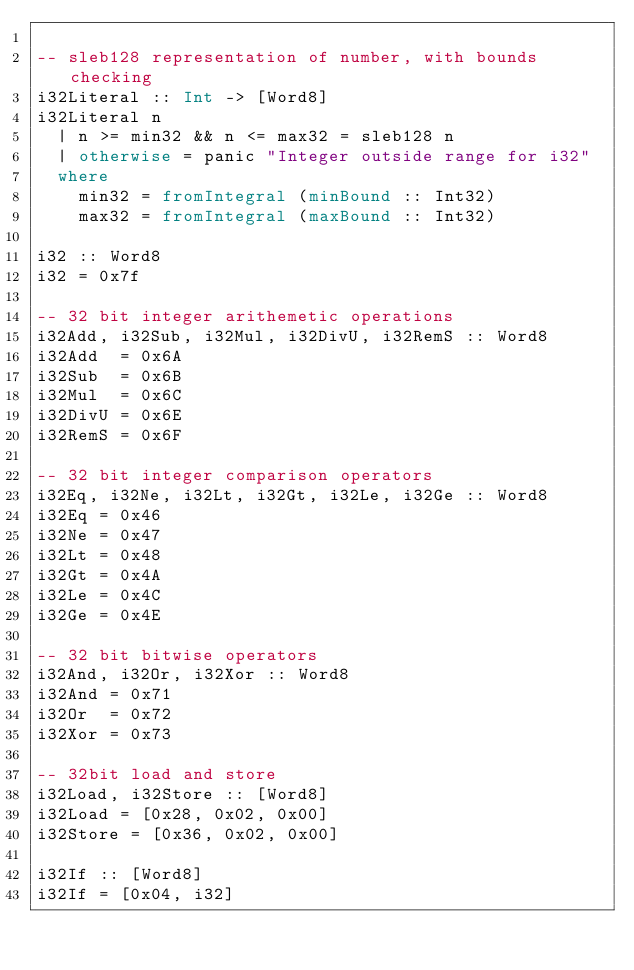Convert code to text. <code><loc_0><loc_0><loc_500><loc_500><_Haskell_>
-- sleb128 representation of number, with bounds checking
i32Literal :: Int -> [Word8]
i32Literal n
  | n >= min32 && n <= max32 = sleb128 n
  | otherwise = panic "Integer outside range for i32"
  where
    min32 = fromIntegral (minBound :: Int32)
    max32 = fromIntegral (maxBound :: Int32)

i32 :: Word8
i32 = 0x7f

-- 32 bit integer arithemetic operations
i32Add, i32Sub, i32Mul, i32DivU, i32RemS :: Word8
i32Add  = 0x6A
i32Sub  = 0x6B
i32Mul  = 0x6C
i32DivU = 0x6E
i32RemS = 0x6F

-- 32 bit integer comparison operators
i32Eq, i32Ne, i32Lt, i32Gt, i32Le, i32Ge :: Word8
i32Eq = 0x46
i32Ne = 0x47
i32Lt = 0x48
i32Gt = 0x4A
i32Le = 0x4C
i32Ge = 0x4E

-- 32 bit bitwise operators
i32And, i32Or, i32Xor :: Word8
i32And = 0x71
i32Or  = 0x72
i32Xor = 0x73

-- 32bit load and store
i32Load, i32Store :: [Word8]
i32Load = [0x28, 0x02, 0x00]
i32Store = [0x36, 0x02, 0x00]

i32If :: [Word8]
i32If = [0x04, i32]
</code> 